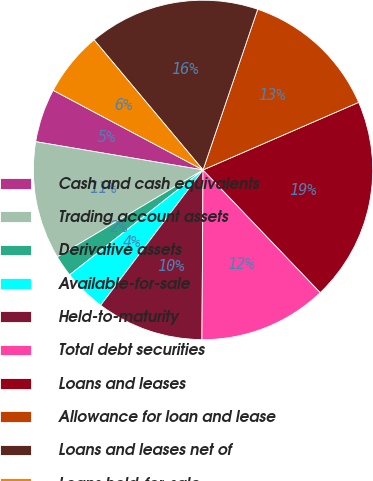<chart> <loc_0><loc_0><loc_500><loc_500><pie_chart><fcel>Cash and cash equivalents<fcel>Trading account assets<fcel>Derivative assets<fcel>Available-for-sale<fcel>Held-to-maturity<fcel>Total debt securities<fcel>Loans and leases<fcel>Allowance for loan and lease<fcel>Loans and leases net of<fcel>Loans held-for-sale<nl><fcel>5.11%<fcel>11.22%<fcel>2.05%<fcel>4.09%<fcel>10.2%<fcel>12.24%<fcel>19.38%<fcel>13.26%<fcel>16.32%<fcel>6.13%<nl></chart> 